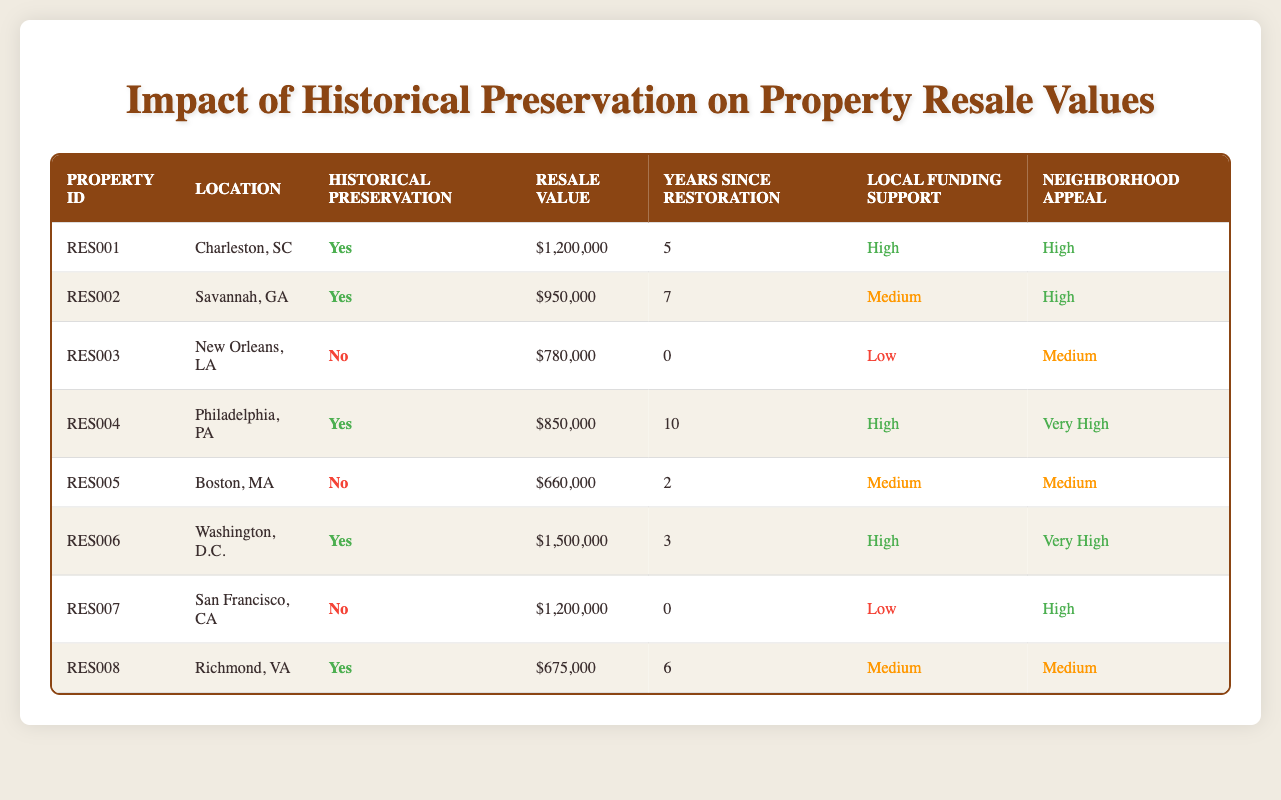What is the resale value of property RES004? The table lists the property ID RES004, and in the corresponding row under the "Resale Value" column, the value shown is $850,000.
Answer: $850,000 How many properties have a high neighborhood aesthetic appeal? In the table, I will filter for the "Neighborhood Appeal" column to identify properties marked as "High" or "Very High." There are 5 properties with such ratings (RES001, RES002, RES004, RES006, RES007).
Answer: 5 What is the average resale value of properties with historical preservation status 'Yes'? I identify all properties with the historical preservation status 'Yes' (RES001, RES002, RES004, RES006, RES008) and sum their resale values: 1,200,000 + 950,000 + 850,000 + 1,500,000 + 675,000 = 5,175,000. There are 5 such properties, so the average is 5,175,000 / 5 = 1,035,000.
Answer: $1,035,000 Is the local funding support for property RES007 high? Within the table, locating RES007 shows that it has a local funding support rating of "Low." Hence, the response is no.
Answer: No What is the difference in resale value between the highest and lowest valued properties? The highest resale value is from RES006 at $1,500,000, while the lowest is RES005 at $660,000. The difference is calculated by subtracting $660,000 from $1,500,000, which gives $840,000.
Answer: $840,000 How many years since restoration does the property with the highest resale value have? Searching through the table, I find that property RES006 has the highest resale value of $1,500,000, and it has been restored for 3 years.
Answer: 3 Which property has the medium level of local funding support? To identify properties with medium local funding support, I filter the "Local Funding Support" column for properties marked as "Medium." The properties are RES002, RES005, and RES008.
Answer: 3 Are all properties without historical preservation initiatives lower in resale value than those with it? Analyzing the table, properties without historical preservation (RES003, RES005, RES007) have resale values of $780,000, $660,000, and $1,200,000, respectively. Among these, one property (RES007) does exceed the lowest property with preservation (RES004 at $850,000), so the statement is false.
Answer: No 